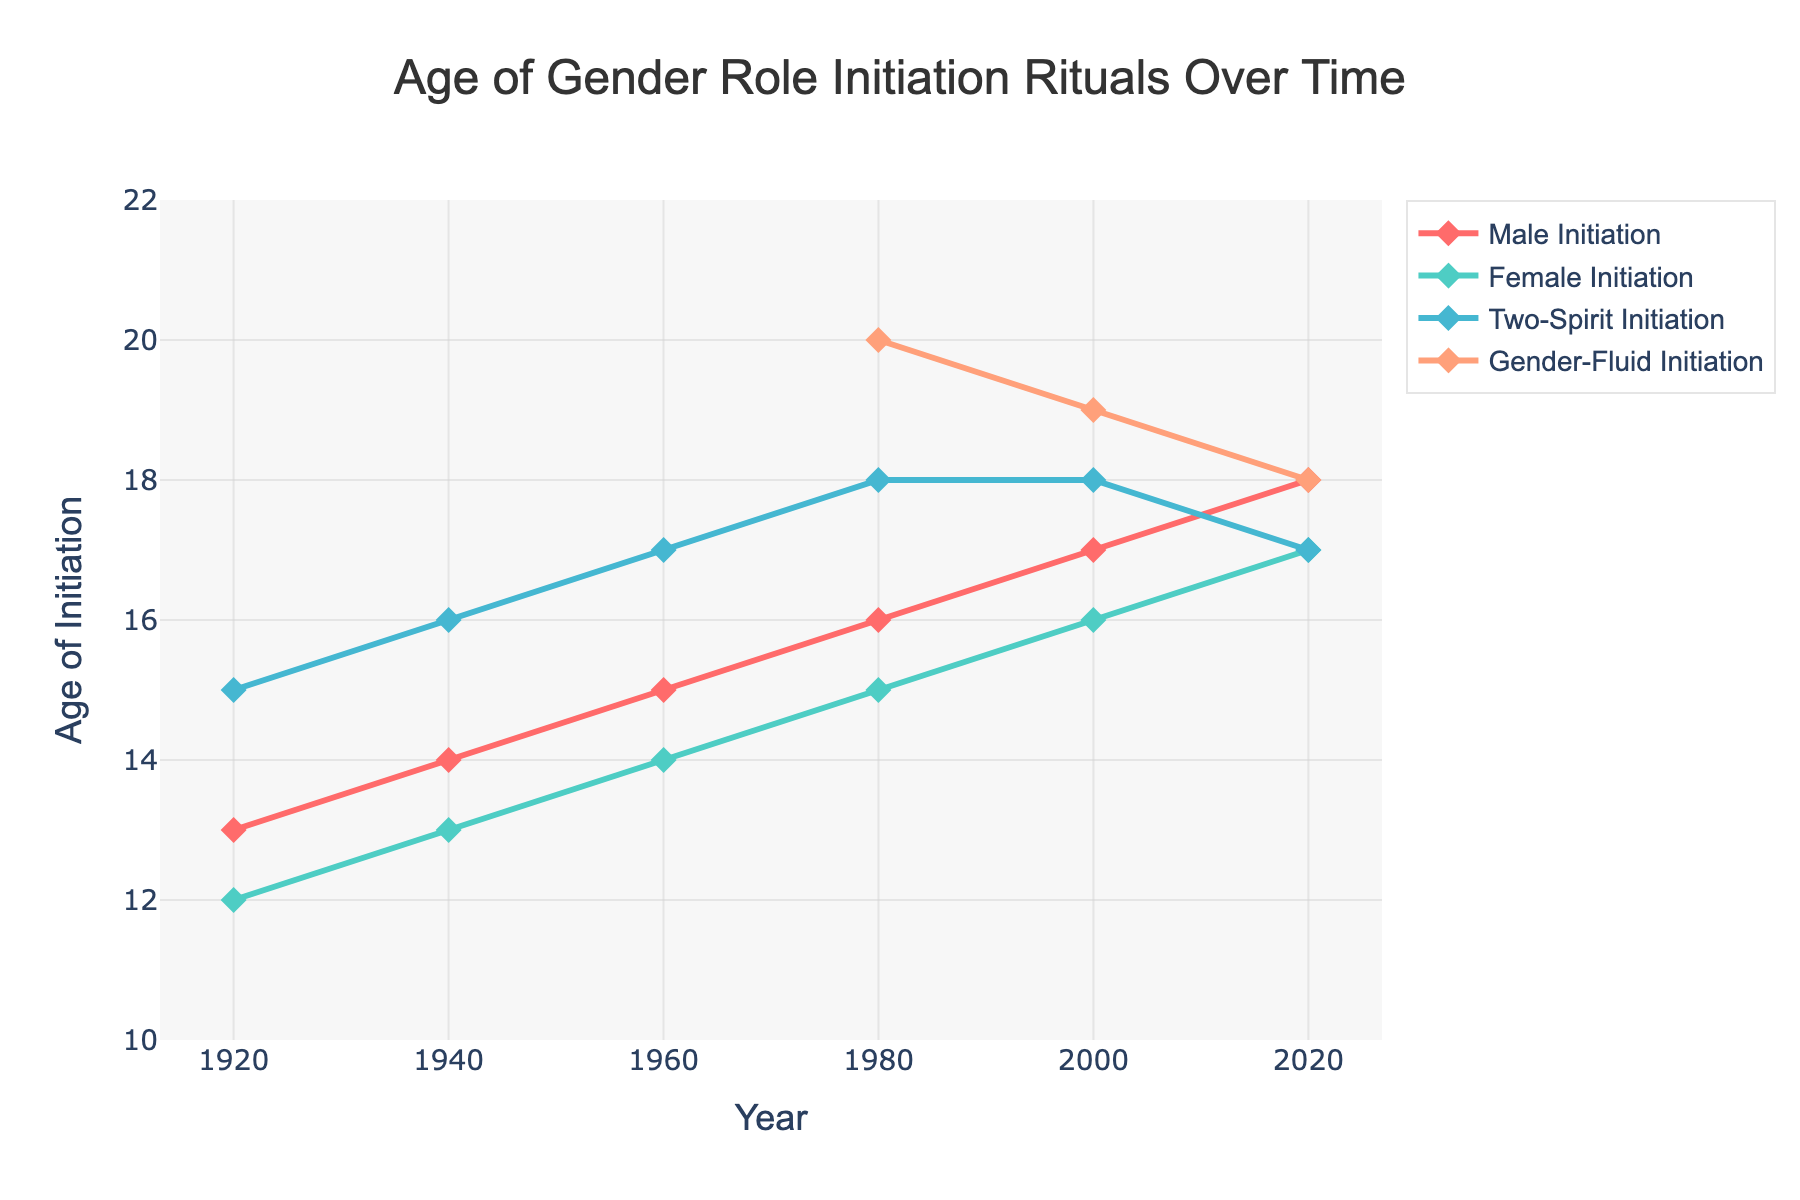What's the starting age of initiation rituals for males in the 1920s? The figure shows a line that starts at 13 years for male initiation rituals in the year 1920, as indicated by the 'Male Initiation' trace
Answer: 13 What is the overall trend in the age of initiation rituals for females over the observed period? The line for female initiation rituals starts at 12 years in 1920 and increases incrementally to 17 years by 2020, indicating a gradual upward trend
Answer: Increasing Between which years did the age of initiation rituals for Two-Spirit identities show no change? The figure shows that the age of Two-Spirit initiation rituals was 18 years in both 1980 and 2000, indicating no change during this period
Answer: 1980 to 2000 How does the age of Gender-Fluid initiation rituals change from 1980 to 2020? The line for Gender-Fluid initiation rituals starts at 20 years in 1980, then gradually decreases to 18 years in 2020
Answer: Decreasing Which gender identity has the highest age of initiation in the year 2000? The age of initiation for Gender-Fluid in 2000 is 19 years, while males, females, and Two-Spirit are at 17, 16, and 18 years respectively
Answer: Gender-Fluid What is the difference in the age of male initiation rituals between 1920 and 2020? The age of male initiation rituals in 1920 is 13 years, and in 2020 it is 18 years. The difference is 18 - 13 = 5 years
Answer: 5 years Which gender identity's initiation age shows the most rapid decrease from 2000 to 2020? Gender-Fluid initiation age drops from 19 years in 2000 to 18 years in 2020, which is 1 year. Two-Spirit shows a decrease from 18 to 17, which is also 1 year. Other identities either increase or remain stable
Answer: Gender-Fluid and Two-Spirit What is the average age of female initiation rituals over the 100-year period? Add the ages: 12 (1920) + 13 (1940) + 14 (1960) + 15 (1980) + 16 (2000) + 17 (2020) = 87. Divide by 6 to get the average: 87 / 6 = 14.5
Answer: 14.5 years Compare the initiation ages for males and females in 1960. Which is higher? The figure shows the initiation age for males in 1960 is 15 years and for females is 14 years, indicating males have a higher initiation age
Answer: Males What is the color used for the line representing Two-Spirit initiation rituals? The trace for Two-Spirit initiation rituals is represented in green color in the plot
Answer: Green 